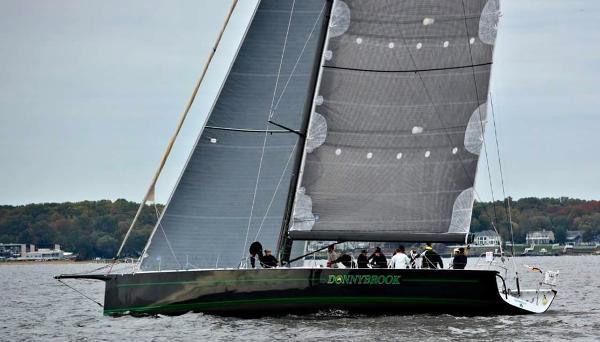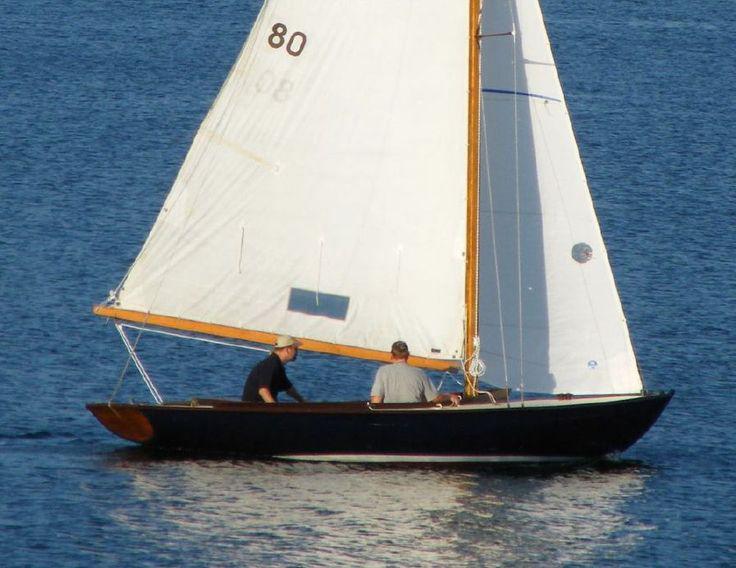The first image is the image on the left, the second image is the image on the right. Evaluate the accuracy of this statement regarding the images: "At least one of the boats has a white hull.". Is it true? Answer yes or no. No. The first image is the image on the left, the second image is the image on the right. For the images displayed, is the sentence "In one of the images there is a lone person sailing a boat in the center of the image." factually correct? Answer yes or no. No. 